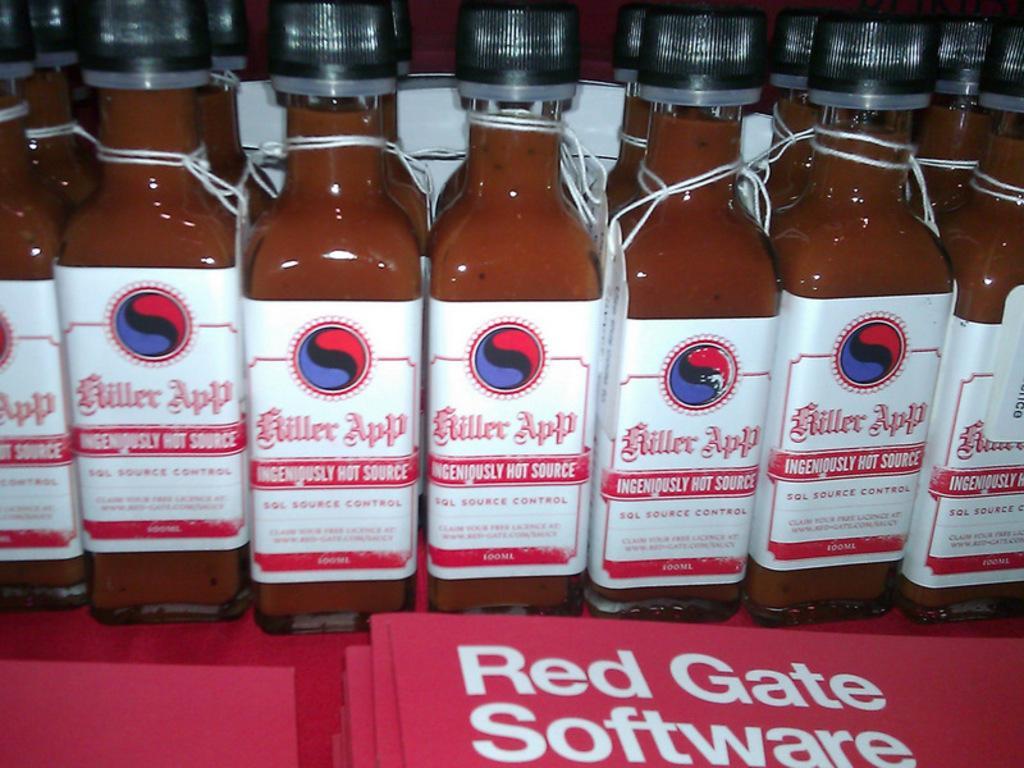Can you describe this image briefly? In this image i can see few bottles. 